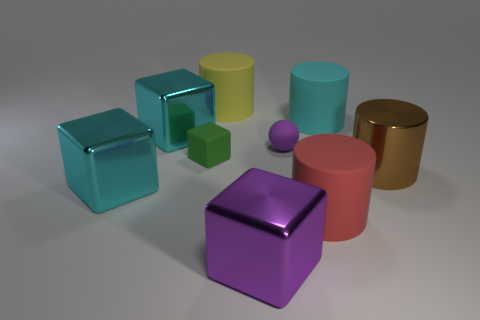What is the brown cylinder made of?
Give a very brief answer. Metal. There is a large cyan rubber cylinder; how many big rubber things are right of it?
Make the answer very short. 0. Is the number of big red rubber cylinders behind the large metal cylinder less than the number of cyan rubber objects in front of the purple matte sphere?
Make the answer very short. No. There is a purple thing that is in front of the cyan metal object that is to the left of the large cyan block behind the green cube; what shape is it?
Offer a terse response. Cube. There is a metallic object that is right of the small rubber block and in front of the large brown object; what shape is it?
Give a very brief answer. Cube. Is there a purple cube that has the same material as the big brown cylinder?
Your answer should be very brief. Yes. The shiny object that is in front of the red cylinder is what color?
Provide a short and direct response. Purple. Do the purple metallic object and the big cyan shiny thing in front of the green rubber thing have the same shape?
Make the answer very short. Yes. Is there a metallic cube that has the same color as the small ball?
Your answer should be very brief. Yes. There is a cyan object that is the same material as the red cylinder; what size is it?
Keep it short and to the point. Large. 